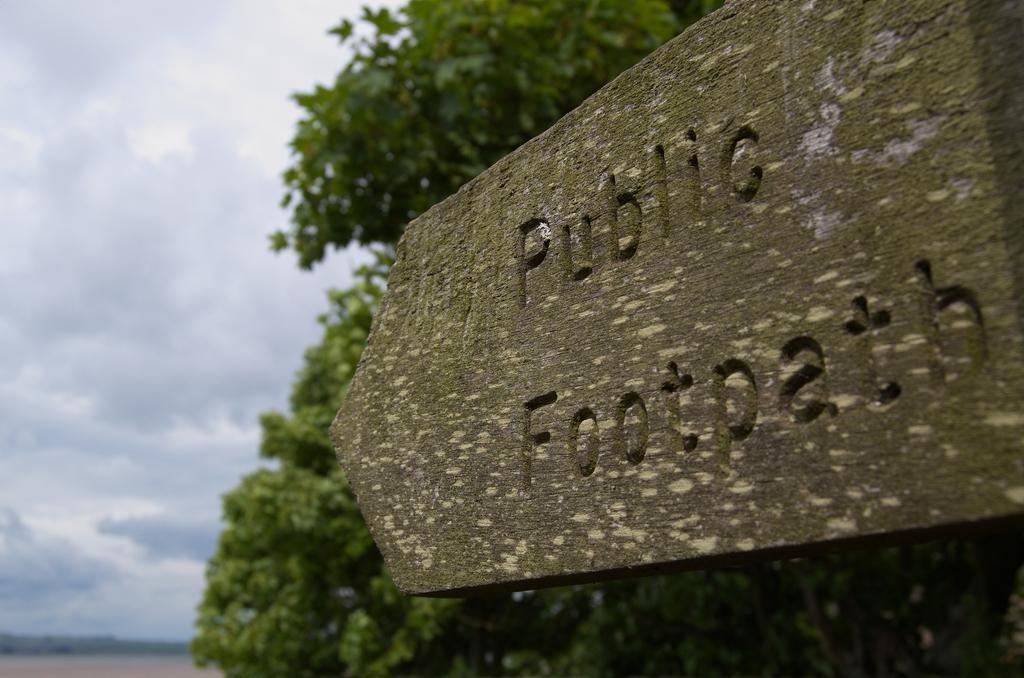Please provide a concise description of this image. In this image, we can see some trees. There is a board in the middle of the image. There are clouds in the sky. 